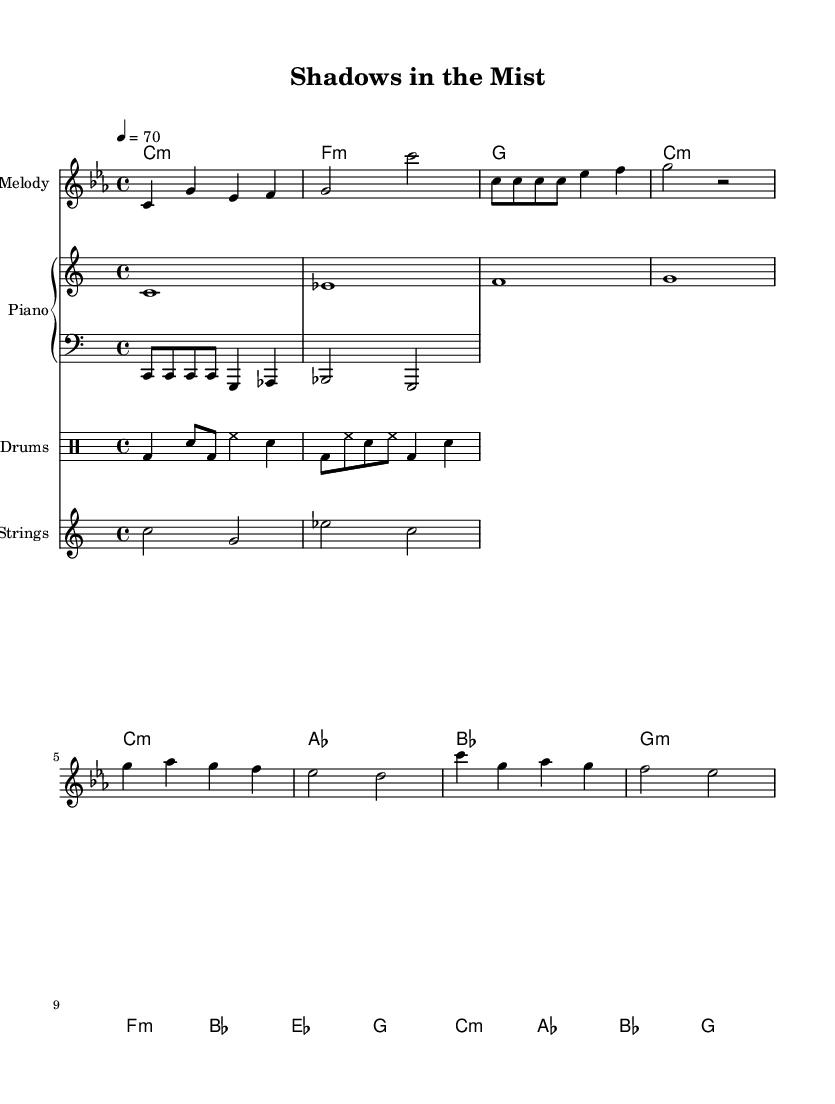What is the key signature of this music? The key signature is C minor, which contains three flats (B flat, E flat, and A flat). It is indicated at the beginning of the score with the clef and the symbol for the key signature.
Answer: C minor What is the time signature of the piece? The time signature is 4/4, which means there are four beats in each measure and the quarter note gets one beat. This is indicated at the beginning of the score right after the key signature.
Answer: 4/4 What is the tempo marking of the composition? The tempo marking is 4 equals 70, which indicates that the quarter note should be played at a speed of 70 beats per minute. This is found in the header section of the score.
Answer: 70 How many sections are in the piece? The piece has four sections labeled as Intro, Verse, Pre-Chorus, and Chorus. These are identifiable by the distinct melodic phrasing and repeat patterns found within the sheet music.
Answer: Four Which instrument plays the bass line? The bass line is indicated to be played by a staff labeled with the clef bass, specifically notated with a lower octave relative to the melody, making it clear that the part is for a bass instrument.
Answer: Bass What is the rhythmic pattern used for the drum section? The rhythmic pattern in the drum section consists of bass drum, snare drum, and hi-hat beats, creating a trap-rap fusion rhythm. This is represented in a specific notation that outlines the sequence of these sounds.
Answer: Trap-rap rhythm What is the chord progression for the chorus? The chord progression for the chorus is C minor, A flat, B flat, G. This can be derived from the chord symbols written above the corresponding measures in the melody line during the chorus section.
Answer: C minor, A flat, B flat, G 